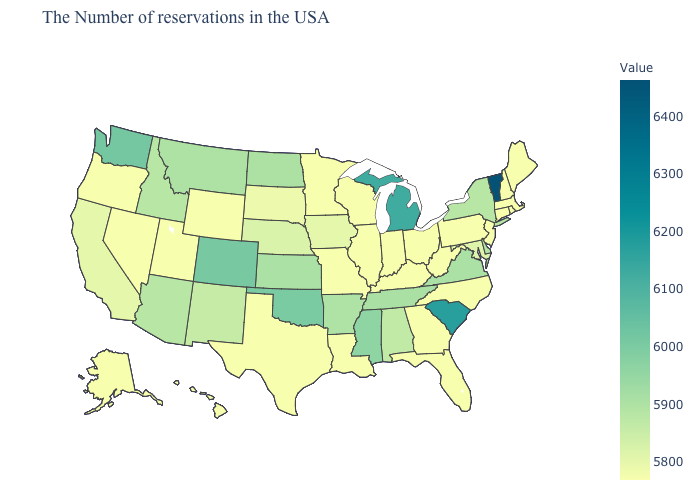Which states have the lowest value in the USA?
Short answer required. Maine, Massachusetts, Rhode Island, New Hampshire, Connecticut, New Jersey, Pennsylvania, North Carolina, West Virginia, Ohio, Florida, Georgia, Kentucky, Indiana, Wisconsin, Illinois, Louisiana, Missouri, Minnesota, Texas, Wyoming, Utah, Nevada, Oregon, Alaska, Hawaii. Is the legend a continuous bar?
Keep it brief. Yes. Does Georgia have the lowest value in the South?
Quick response, please. Yes. Which states have the lowest value in the Northeast?
Keep it brief. Maine, Massachusetts, Rhode Island, New Hampshire, Connecticut, New Jersey, Pennsylvania. Which states have the lowest value in the USA?
Concise answer only. Maine, Massachusetts, Rhode Island, New Hampshire, Connecticut, New Jersey, Pennsylvania, North Carolina, West Virginia, Ohio, Florida, Georgia, Kentucky, Indiana, Wisconsin, Illinois, Louisiana, Missouri, Minnesota, Texas, Wyoming, Utah, Nevada, Oregon, Alaska, Hawaii. Does the map have missing data?
Concise answer only. No. Is the legend a continuous bar?
Short answer required. Yes. Which states have the lowest value in the USA?
Concise answer only. Maine, Massachusetts, Rhode Island, New Hampshire, Connecticut, New Jersey, Pennsylvania, North Carolina, West Virginia, Ohio, Florida, Georgia, Kentucky, Indiana, Wisconsin, Illinois, Louisiana, Missouri, Minnesota, Texas, Wyoming, Utah, Nevada, Oregon, Alaska, Hawaii. 